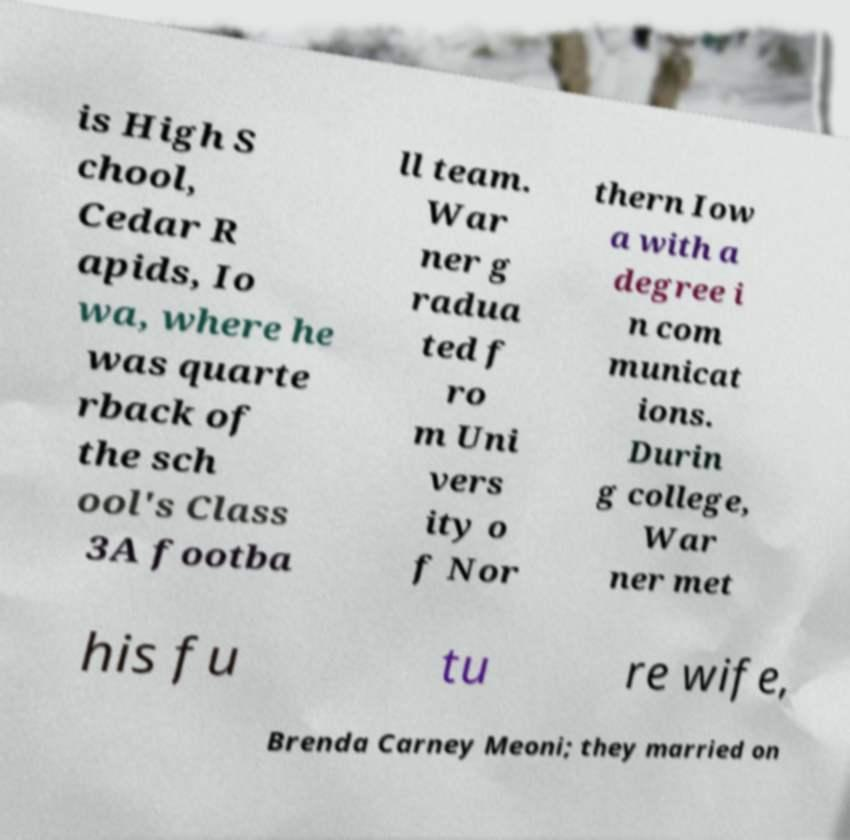Can you accurately transcribe the text from the provided image for me? is High S chool, Cedar R apids, Io wa, where he was quarte rback of the sch ool's Class 3A footba ll team. War ner g radua ted f ro m Uni vers ity o f Nor thern Iow a with a degree i n com municat ions. Durin g college, War ner met his fu tu re wife, Brenda Carney Meoni; they married on 